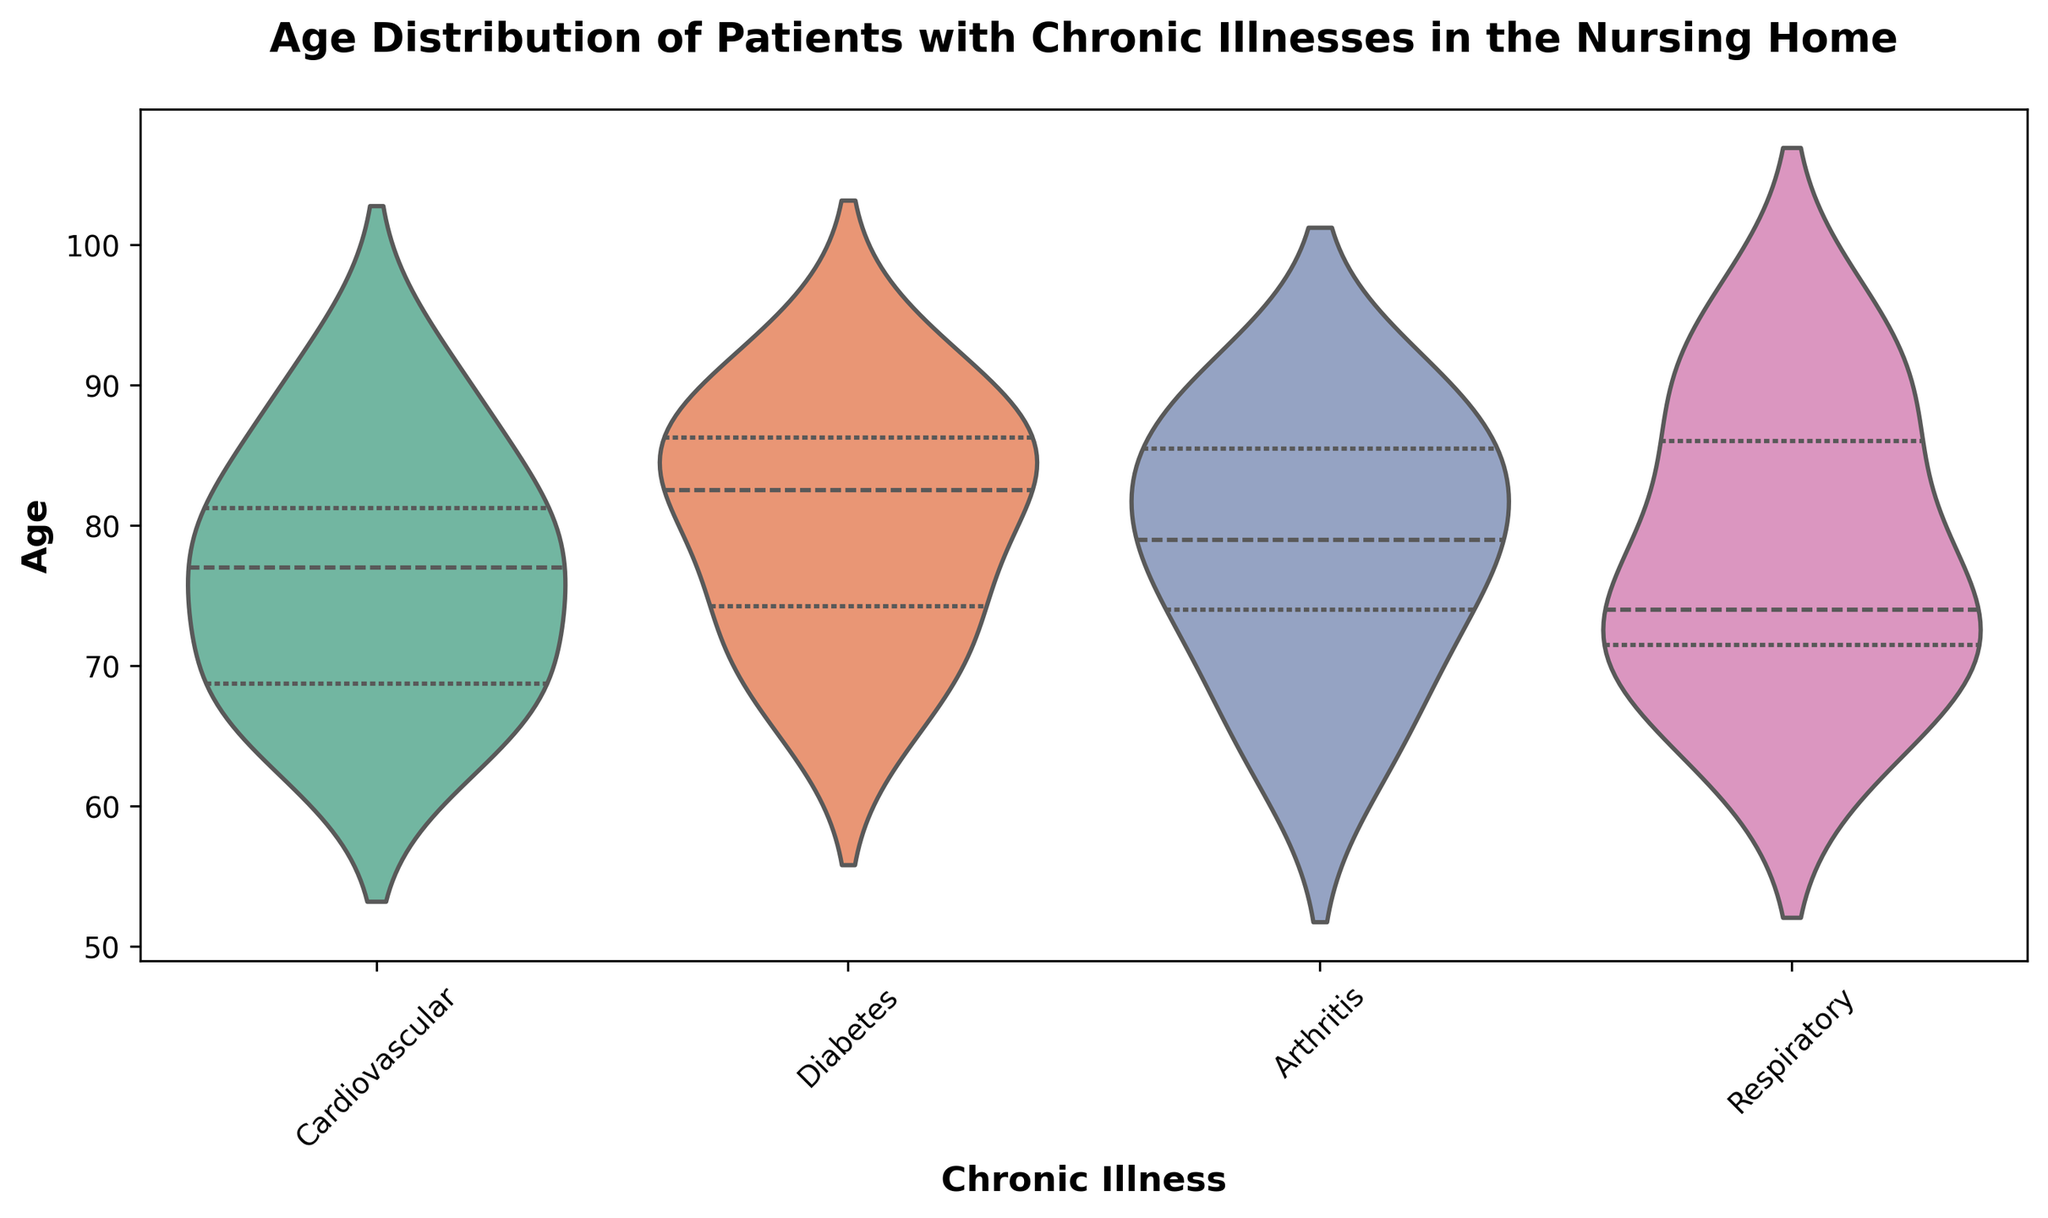What's the median age of patients with Cardiovascular illnesses? To determine the median age, locate the middle value when the ages are ordered from lowest to highest within the Cardiovascular group. The median is the central point of the distribution shown by the white line within the violin plot.
Answer: 76 Which illness group has the widest age distribution? Look at the violin plots for each illness and compare their widths. The group with the widest plot represents the largest range of ages. The Arthritis group shows the widest distribution, indicating a larger age range.
Answer: Arthritis What is the age range for patients with Respiratory illnesses? The age range is the difference between the maximum and minimum ages. For the Respiratory group, observe the top and bottom edges of the violin plot. The range is from 66 to 93.
Answer: 27 Which illness group has the highest median age? Compare the white lines representing the medians across the groups. The Respiratory group’s median line is located higher than the others.
Answer: Respiratory What is the interquartile range (IQR) of age for patients with Diabetes? The IQR is the range within which the central 50% of values lie, represented by the thick bar in the violin plot. For the Diabetes group, observe the range this bar covers. The IQR is from 72 to 88.
Answer: 16 Are the age distributions of any illness groups symmetrically distributed? A symmetric distribution has a violin plot that is mirrored about its center. Check if any violin plots look symmetrical. The Diabetes group's distribution appears relatively symmetric.
Answer: Diabetes What can be inferred about the age distribution of the Respiratory group compared to Arthritis? Examine the shapes and positions of the violins. The Respiratory group shows a more centralized distribution, while the Arthritis group is more spread out, implying more variability in age.
Answer: Respiratory is more centralized, Arthritis is more spread out Which illness group has the smallest range in ages? Compare the lengths of the violin plots. The Cardiovascular group has the shortest plot, indicating the smallest age range.
Answer: Cardiovascular 